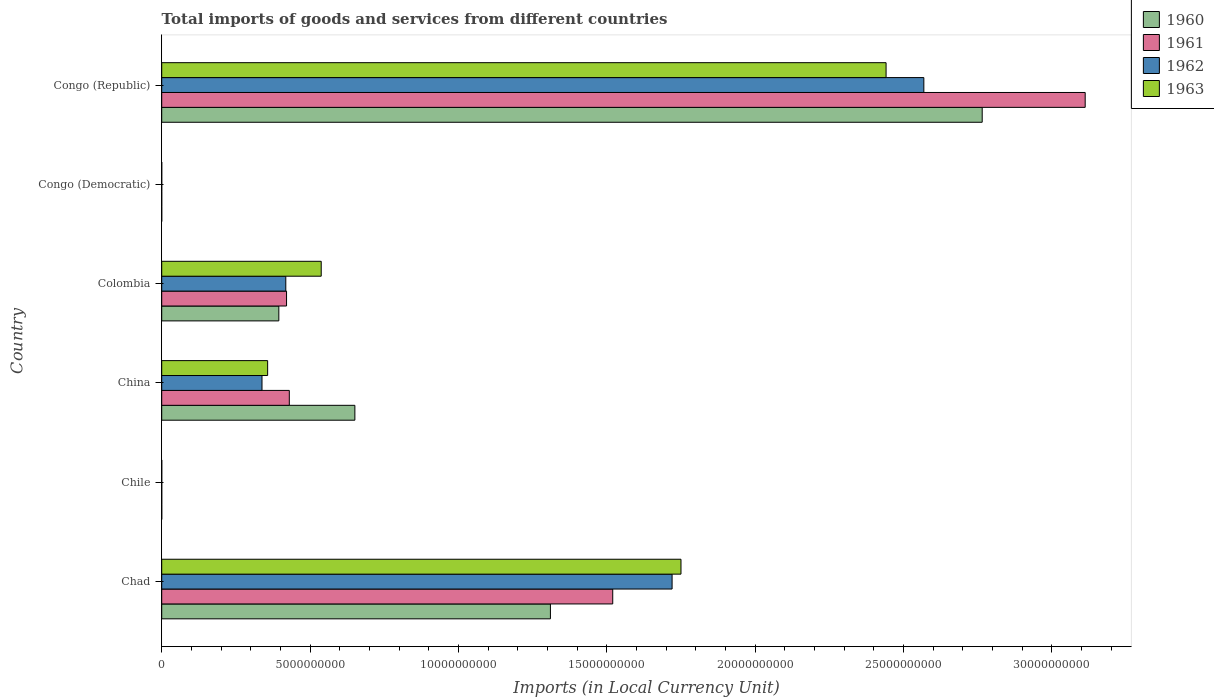How many different coloured bars are there?
Provide a succinct answer. 4. Are the number of bars per tick equal to the number of legend labels?
Your answer should be compact. Yes. How many bars are there on the 2nd tick from the bottom?
Provide a succinct answer. 4. What is the label of the 3rd group of bars from the top?
Ensure brevity in your answer.  Colombia. In how many cases, is the number of bars for a given country not equal to the number of legend labels?
Ensure brevity in your answer.  0. What is the Amount of goods and services imports in 1962 in Congo (Republic)?
Offer a terse response. 2.57e+1. Across all countries, what is the maximum Amount of goods and services imports in 1961?
Offer a terse response. 3.11e+1. Across all countries, what is the minimum Amount of goods and services imports in 1961?
Make the answer very short. 5.07076656504069e-5. In which country was the Amount of goods and services imports in 1963 maximum?
Offer a very short reply. Congo (Republic). In which country was the Amount of goods and services imports in 1961 minimum?
Your answer should be very brief. Congo (Democratic). What is the total Amount of goods and services imports in 1962 in the graph?
Your response must be concise. 5.04e+1. What is the difference between the Amount of goods and services imports in 1960 in Colombia and that in Congo (Republic)?
Make the answer very short. -2.37e+1. What is the difference between the Amount of goods and services imports in 1961 in Chad and the Amount of goods and services imports in 1962 in China?
Ensure brevity in your answer.  1.18e+1. What is the average Amount of goods and services imports in 1963 per country?
Give a very brief answer. 8.48e+09. What is the difference between the Amount of goods and services imports in 1963 and Amount of goods and services imports in 1962 in Colombia?
Your response must be concise. 1.19e+09. What is the ratio of the Amount of goods and services imports in 1960 in Chile to that in Congo (Democratic)?
Give a very brief answer. 6.31e+09. Is the Amount of goods and services imports in 1961 in Chile less than that in Congo (Democratic)?
Offer a very short reply. No. What is the difference between the highest and the second highest Amount of goods and services imports in 1961?
Your answer should be compact. 1.59e+1. What is the difference between the highest and the lowest Amount of goods and services imports in 1963?
Keep it short and to the point. 2.44e+1. Is it the case that in every country, the sum of the Amount of goods and services imports in 1963 and Amount of goods and services imports in 1960 is greater than the sum of Amount of goods and services imports in 1961 and Amount of goods and services imports in 1962?
Provide a short and direct response. No. What does the 1st bar from the top in China represents?
Ensure brevity in your answer.  1963. How many bars are there?
Keep it short and to the point. 24. Are all the bars in the graph horizontal?
Offer a terse response. Yes. How many countries are there in the graph?
Your answer should be compact. 6. Does the graph contain grids?
Keep it short and to the point. No. Where does the legend appear in the graph?
Keep it short and to the point. Top right. How many legend labels are there?
Ensure brevity in your answer.  4. How are the legend labels stacked?
Provide a succinct answer. Vertical. What is the title of the graph?
Offer a terse response. Total imports of goods and services from different countries. Does "1960" appear as one of the legend labels in the graph?
Your answer should be compact. Yes. What is the label or title of the X-axis?
Your response must be concise. Imports (in Local Currency Unit). What is the label or title of the Y-axis?
Provide a short and direct response. Country. What is the Imports (in Local Currency Unit) of 1960 in Chad?
Your answer should be compact. 1.31e+1. What is the Imports (in Local Currency Unit) in 1961 in Chad?
Your answer should be compact. 1.52e+1. What is the Imports (in Local Currency Unit) in 1962 in Chad?
Offer a very short reply. 1.72e+1. What is the Imports (in Local Currency Unit) in 1963 in Chad?
Your response must be concise. 1.75e+1. What is the Imports (in Local Currency Unit) of 1962 in Chile?
Offer a terse response. 8.00e+05. What is the Imports (in Local Currency Unit) of 1963 in Chile?
Make the answer very short. 1.30e+06. What is the Imports (in Local Currency Unit) in 1960 in China?
Your answer should be compact. 6.51e+09. What is the Imports (in Local Currency Unit) of 1961 in China?
Provide a succinct answer. 4.30e+09. What is the Imports (in Local Currency Unit) in 1962 in China?
Give a very brief answer. 3.38e+09. What is the Imports (in Local Currency Unit) in 1963 in China?
Offer a terse response. 3.57e+09. What is the Imports (in Local Currency Unit) in 1960 in Colombia?
Offer a terse response. 3.95e+09. What is the Imports (in Local Currency Unit) in 1961 in Colombia?
Your answer should be very brief. 4.21e+09. What is the Imports (in Local Currency Unit) in 1962 in Colombia?
Provide a short and direct response. 4.18e+09. What is the Imports (in Local Currency Unit) of 1963 in Colombia?
Your response must be concise. 5.38e+09. What is the Imports (in Local Currency Unit) of 1960 in Congo (Democratic)?
Make the answer very short. 0. What is the Imports (in Local Currency Unit) in 1961 in Congo (Democratic)?
Offer a terse response. 5.07076656504069e-5. What is the Imports (in Local Currency Unit) in 1962 in Congo (Democratic)?
Offer a terse response. 5.906629303353841e-5. What is the Imports (in Local Currency Unit) of 1963 in Congo (Democratic)?
Provide a succinct answer. 0. What is the Imports (in Local Currency Unit) in 1960 in Congo (Republic)?
Give a very brief answer. 2.77e+1. What is the Imports (in Local Currency Unit) in 1961 in Congo (Republic)?
Your answer should be compact. 3.11e+1. What is the Imports (in Local Currency Unit) of 1962 in Congo (Republic)?
Your response must be concise. 2.57e+1. What is the Imports (in Local Currency Unit) of 1963 in Congo (Republic)?
Offer a very short reply. 2.44e+1. Across all countries, what is the maximum Imports (in Local Currency Unit) of 1960?
Make the answer very short. 2.77e+1. Across all countries, what is the maximum Imports (in Local Currency Unit) of 1961?
Your answer should be very brief. 3.11e+1. Across all countries, what is the maximum Imports (in Local Currency Unit) of 1962?
Your answer should be very brief. 2.57e+1. Across all countries, what is the maximum Imports (in Local Currency Unit) in 1963?
Your answer should be very brief. 2.44e+1. Across all countries, what is the minimum Imports (in Local Currency Unit) in 1960?
Provide a succinct answer. 0. Across all countries, what is the minimum Imports (in Local Currency Unit) in 1961?
Provide a short and direct response. 5.07076656504069e-5. Across all countries, what is the minimum Imports (in Local Currency Unit) of 1962?
Provide a succinct answer. 5.906629303353841e-5. Across all countries, what is the minimum Imports (in Local Currency Unit) of 1963?
Your answer should be very brief. 0. What is the total Imports (in Local Currency Unit) in 1960 in the graph?
Offer a terse response. 5.12e+1. What is the total Imports (in Local Currency Unit) of 1961 in the graph?
Give a very brief answer. 5.48e+1. What is the total Imports (in Local Currency Unit) in 1962 in the graph?
Give a very brief answer. 5.04e+1. What is the total Imports (in Local Currency Unit) of 1963 in the graph?
Make the answer very short. 5.09e+1. What is the difference between the Imports (in Local Currency Unit) in 1960 in Chad and that in Chile?
Make the answer very short. 1.31e+1. What is the difference between the Imports (in Local Currency Unit) of 1961 in Chad and that in Chile?
Offer a very short reply. 1.52e+1. What is the difference between the Imports (in Local Currency Unit) of 1962 in Chad and that in Chile?
Ensure brevity in your answer.  1.72e+1. What is the difference between the Imports (in Local Currency Unit) of 1963 in Chad and that in Chile?
Offer a very short reply. 1.75e+1. What is the difference between the Imports (in Local Currency Unit) in 1960 in Chad and that in China?
Your response must be concise. 6.59e+09. What is the difference between the Imports (in Local Currency Unit) of 1961 in Chad and that in China?
Provide a succinct answer. 1.09e+1. What is the difference between the Imports (in Local Currency Unit) in 1962 in Chad and that in China?
Your answer should be compact. 1.38e+1. What is the difference between the Imports (in Local Currency Unit) of 1963 in Chad and that in China?
Your response must be concise. 1.39e+1. What is the difference between the Imports (in Local Currency Unit) in 1960 in Chad and that in Colombia?
Offer a terse response. 9.15e+09. What is the difference between the Imports (in Local Currency Unit) of 1961 in Chad and that in Colombia?
Offer a very short reply. 1.10e+1. What is the difference between the Imports (in Local Currency Unit) of 1962 in Chad and that in Colombia?
Provide a succinct answer. 1.30e+1. What is the difference between the Imports (in Local Currency Unit) of 1963 in Chad and that in Colombia?
Provide a succinct answer. 1.21e+1. What is the difference between the Imports (in Local Currency Unit) of 1960 in Chad and that in Congo (Democratic)?
Offer a very short reply. 1.31e+1. What is the difference between the Imports (in Local Currency Unit) in 1961 in Chad and that in Congo (Democratic)?
Your answer should be compact. 1.52e+1. What is the difference between the Imports (in Local Currency Unit) of 1962 in Chad and that in Congo (Democratic)?
Provide a short and direct response. 1.72e+1. What is the difference between the Imports (in Local Currency Unit) of 1963 in Chad and that in Congo (Democratic)?
Ensure brevity in your answer.  1.75e+1. What is the difference between the Imports (in Local Currency Unit) in 1960 in Chad and that in Congo (Republic)?
Offer a terse response. -1.46e+1. What is the difference between the Imports (in Local Currency Unit) of 1961 in Chad and that in Congo (Republic)?
Your answer should be very brief. -1.59e+1. What is the difference between the Imports (in Local Currency Unit) of 1962 in Chad and that in Congo (Republic)?
Your answer should be very brief. -8.48e+09. What is the difference between the Imports (in Local Currency Unit) of 1963 in Chad and that in Congo (Republic)?
Keep it short and to the point. -6.91e+09. What is the difference between the Imports (in Local Currency Unit) of 1960 in Chile and that in China?
Offer a very short reply. -6.51e+09. What is the difference between the Imports (in Local Currency Unit) of 1961 in Chile and that in China?
Your answer should be very brief. -4.30e+09. What is the difference between the Imports (in Local Currency Unit) in 1962 in Chile and that in China?
Give a very brief answer. -3.38e+09. What is the difference between the Imports (in Local Currency Unit) in 1963 in Chile and that in China?
Your answer should be compact. -3.57e+09. What is the difference between the Imports (in Local Currency Unit) in 1960 in Chile and that in Colombia?
Ensure brevity in your answer.  -3.95e+09. What is the difference between the Imports (in Local Currency Unit) of 1961 in Chile and that in Colombia?
Provide a short and direct response. -4.21e+09. What is the difference between the Imports (in Local Currency Unit) of 1962 in Chile and that in Colombia?
Your answer should be compact. -4.18e+09. What is the difference between the Imports (in Local Currency Unit) in 1963 in Chile and that in Colombia?
Give a very brief answer. -5.37e+09. What is the difference between the Imports (in Local Currency Unit) of 1960 in Chile and that in Congo (Democratic)?
Your response must be concise. 7.00e+05. What is the difference between the Imports (in Local Currency Unit) of 1961 in Chile and that in Congo (Democratic)?
Keep it short and to the point. 8.00e+05. What is the difference between the Imports (in Local Currency Unit) in 1962 in Chile and that in Congo (Democratic)?
Provide a succinct answer. 8.00e+05. What is the difference between the Imports (in Local Currency Unit) in 1963 in Chile and that in Congo (Democratic)?
Ensure brevity in your answer.  1.30e+06. What is the difference between the Imports (in Local Currency Unit) of 1960 in Chile and that in Congo (Republic)?
Provide a short and direct response. -2.77e+1. What is the difference between the Imports (in Local Currency Unit) of 1961 in Chile and that in Congo (Republic)?
Give a very brief answer. -3.11e+1. What is the difference between the Imports (in Local Currency Unit) of 1962 in Chile and that in Congo (Republic)?
Offer a very short reply. -2.57e+1. What is the difference between the Imports (in Local Currency Unit) of 1963 in Chile and that in Congo (Republic)?
Your response must be concise. -2.44e+1. What is the difference between the Imports (in Local Currency Unit) of 1960 in China and that in Colombia?
Offer a very short reply. 2.56e+09. What is the difference between the Imports (in Local Currency Unit) in 1961 in China and that in Colombia?
Provide a succinct answer. 9.28e+07. What is the difference between the Imports (in Local Currency Unit) in 1962 in China and that in Colombia?
Your answer should be very brief. -8.02e+08. What is the difference between the Imports (in Local Currency Unit) of 1963 in China and that in Colombia?
Your response must be concise. -1.81e+09. What is the difference between the Imports (in Local Currency Unit) in 1960 in China and that in Congo (Democratic)?
Ensure brevity in your answer.  6.51e+09. What is the difference between the Imports (in Local Currency Unit) in 1961 in China and that in Congo (Democratic)?
Give a very brief answer. 4.30e+09. What is the difference between the Imports (in Local Currency Unit) in 1962 in China and that in Congo (Democratic)?
Your answer should be compact. 3.38e+09. What is the difference between the Imports (in Local Currency Unit) in 1963 in China and that in Congo (Democratic)?
Your answer should be very brief. 3.57e+09. What is the difference between the Imports (in Local Currency Unit) in 1960 in China and that in Congo (Republic)?
Offer a terse response. -2.11e+1. What is the difference between the Imports (in Local Currency Unit) in 1961 in China and that in Congo (Republic)?
Give a very brief answer. -2.68e+1. What is the difference between the Imports (in Local Currency Unit) in 1962 in China and that in Congo (Republic)?
Ensure brevity in your answer.  -2.23e+1. What is the difference between the Imports (in Local Currency Unit) of 1963 in China and that in Congo (Republic)?
Your answer should be very brief. -2.08e+1. What is the difference between the Imports (in Local Currency Unit) in 1960 in Colombia and that in Congo (Democratic)?
Offer a terse response. 3.95e+09. What is the difference between the Imports (in Local Currency Unit) in 1961 in Colombia and that in Congo (Democratic)?
Your response must be concise. 4.21e+09. What is the difference between the Imports (in Local Currency Unit) of 1962 in Colombia and that in Congo (Democratic)?
Offer a very short reply. 4.18e+09. What is the difference between the Imports (in Local Currency Unit) in 1963 in Colombia and that in Congo (Democratic)?
Ensure brevity in your answer.  5.38e+09. What is the difference between the Imports (in Local Currency Unit) in 1960 in Colombia and that in Congo (Republic)?
Provide a succinct answer. -2.37e+1. What is the difference between the Imports (in Local Currency Unit) in 1961 in Colombia and that in Congo (Republic)?
Your answer should be compact. -2.69e+1. What is the difference between the Imports (in Local Currency Unit) in 1962 in Colombia and that in Congo (Republic)?
Provide a short and direct response. -2.15e+1. What is the difference between the Imports (in Local Currency Unit) in 1963 in Colombia and that in Congo (Republic)?
Make the answer very short. -1.90e+1. What is the difference between the Imports (in Local Currency Unit) in 1960 in Congo (Democratic) and that in Congo (Republic)?
Offer a terse response. -2.77e+1. What is the difference between the Imports (in Local Currency Unit) of 1961 in Congo (Democratic) and that in Congo (Republic)?
Your answer should be compact. -3.11e+1. What is the difference between the Imports (in Local Currency Unit) in 1962 in Congo (Democratic) and that in Congo (Republic)?
Ensure brevity in your answer.  -2.57e+1. What is the difference between the Imports (in Local Currency Unit) of 1963 in Congo (Democratic) and that in Congo (Republic)?
Provide a succinct answer. -2.44e+1. What is the difference between the Imports (in Local Currency Unit) in 1960 in Chad and the Imports (in Local Currency Unit) in 1961 in Chile?
Offer a terse response. 1.31e+1. What is the difference between the Imports (in Local Currency Unit) in 1960 in Chad and the Imports (in Local Currency Unit) in 1962 in Chile?
Your answer should be compact. 1.31e+1. What is the difference between the Imports (in Local Currency Unit) in 1960 in Chad and the Imports (in Local Currency Unit) in 1963 in Chile?
Provide a short and direct response. 1.31e+1. What is the difference between the Imports (in Local Currency Unit) of 1961 in Chad and the Imports (in Local Currency Unit) of 1962 in Chile?
Ensure brevity in your answer.  1.52e+1. What is the difference between the Imports (in Local Currency Unit) in 1961 in Chad and the Imports (in Local Currency Unit) in 1963 in Chile?
Provide a short and direct response. 1.52e+1. What is the difference between the Imports (in Local Currency Unit) of 1962 in Chad and the Imports (in Local Currency Unit) of 1963 in Chile?
Offer a terse response. 1.72e+1. What is the difference between the Imports (in Local Currency Unit) in 1960 in Chad and the Imports (in Local Currency Unit) in 1961 in China?
Offer a very short reply. 8.80e+09. What is the difference between the Imports (in Local Currency Unit) of 1960 in Chad and the Imports (in Local Currency Unit) of 1962 in China?
Keep it short and to the point. 9.72e+09. What is the difference between the Imports (in Local Currency Unit) in 1960 in Chad and the Imports (in Local Currency Unit) in 1963 in China?
Keep it short and to the point. 9.53e+09. What is the difference between the Imports (in Local Currency Unit) of 1961 in Chad and the Imports (in Local Currency Unit) of 1962 in China?
Your answer should be compact. 1.18e+1. What is the difference between the Imports (in Local Currency Unit) of 1961 in Chad and the Imports (in Local Currency Unit) of 1963 in China?
Provide a short and direct response. 1.16e+1. What is the difference between the Imports (in Local Currency Unit) in 1962 in Chad and the Imports (in Local Currency Unit) in 1963 in China?
Provide a short and direct response. 1.36e+1. What is the difference between the Imports (in Local Currency Unit) of 1960 in Chad and the Imports (in Local Currency Unit) of 1961 in Colombia?
Offer a very short reply. 8.89e+09. What is the difference between the Imports (in Local Currency Unit) in 1960 in Chad and the Imports (in Local Currency Unit) in 1962 in Colombia?
Make the answer very short. 8.92e+09. What is the difference between the Imports (in Local Currency Unit) in 1960 in Chad and the Imports (in Local Currency Unit) in 1963 in Colombia?
Your answer should be very brief. 7.72e+09. What is the difference between the Imports (in Local Currency Unit) of 1961 in Chad and the Imports (in Local Currency Unit) of 1962 in Colombia?
Your answer should be very brief. 1.10e+1. What is the difference between the Imports (in Local Currency Unit) of 1961 in Chad and the Imports (in Local Currency Unit) of 1963 in Colombia?
Provide a short and direct response. 9.82e+09. What is the difference between the Imports (in Local Currency Unit) of 1962 in Chad and the Imports (in Local Currency Unit) of 1963 in Colombia?
Keep it short and to the point. 1.18e+1. What is the difference between the Imports (in Local Currency Unit) in 1960 in Chad and the Imports (in Local Currency Unit) in 1961 in Congo (Democratic)?
Make the answer very short. 1.31e+1. What is the difference between the Imports (in Local Currency Unit) of 1960 in Chad and the Imports (in Local Currency Unit) of 1962 in Congo (Democratic)?
Your answer should be very brief. 1.31e+1. What is the difference between the Imports (in Local Currency Unit) in 1960 in Chad and the Imports (in Local Currency Unit) in 1963 in Congo (Democratic)?
Provide a short and direct response. 1.31e+1. What is the difference between the Imports (in Local Currency Unit) of 1961 in Chad and the Imports (in Local Currency Unit) of 1962 in Congo (Democratic)?
Give a very brief answer. 1.52e+1. What is the difference between the Imports (in Local Currency Unit) in 1961 in Chad and the Imports (in Local Currency Unit) in 1963 in Congo (Democratic)?
Your answer should be very brief. 1.52e+1. What is the difference between the Imports (in Local Currency Unit) of 1962 in Chad and the Imports (in Local Currency Unit) of 1963 in Congo (Democratic)?
Your response must be concise. 1.72e+1. What is the difference between the Imports (in Local Currency Unit) in 1960 in Chad and the Imports (in Local Currency Unit) in 1961 in Congo (Republic)?
Offer a very short reply. -1.80e+1. What is the difference between the Imports (in Local Currency Unit) in 1960 in Chad and the Imports (in Local Currency Unit) in 1962 in Congo (Republic)?
Keep it short and to the point. -1.26e+1. What is the difference between the Imports (in Local Currency Unit) of 1960 in Chad and the Imports (in Local Currency Unit) of 1963 in Congo (Republic)?
Provide a succinct answer. -1.13e+1. What is the difference between the Imports (in Local Currency Unit) of 1961 in Chad and the Imports (in Local Currency Unit) of 1962 in Congo (Republic)?
Provide a succinct answer. -1.05e+1. What is the difference between the Imports (in Local Currency Unit) of 1961 in Chad and the Imports (in Local Currency Unit) of 1963 in Congo (Republic)?
Make the answer very short. -9.21e+09. What is the difference between the Imports (in Local Currency Unit) of 1962 in Chad and the Imports (in Local Currency Unit) of 1963 in Congo (Republic)?
Your answer should be compact. -7.21e+09. What is the difference between the Imports (in Local Currency Unit) in 1960 in Chile and the Imports (in Local Currency Unit) in 1961 in China?
Keep it short and to the point. -4.30e+09. What is the difference between the Imports (in Local Currency Unit) of 1960 in Chile and the Imports (in Local Currency Unit) of 1962 in China?
Give a very brief answer. -3.38e+09. What is the difference between the Imports (in Local Currency Unit) in 1960 in Chile and the Imports (in Local Currency Unit) in 1963 in China?
Offer a very short reply. -3.57e+09. What is the difference between the Imports (in Local Currency Unit) in 1961 in Chile and the Imports (in Local Currency Unit) in 1962 in China?
Your answer should be compact. -3.38e+09. What is the difference between the Imports (in Local Currency Unit) of 1961 in Chile and the Imports (in Local Currency Unit) of 1963 in China?
Ensure brevity in your answer.  -3.57e+09. What is the difference between the Imports (in Local Currency Unit) of 1962 in Chile and the Imports (in Local Currency Unit) of 1963 in China?
Ensure brevity in your answer.  -3.57e+09. What is the difference between the Imports (in Local Currency Unit) in 1960 in Chile and the Imports (in Local Currency Unit) in 1961 in Colombia?
Make the answer very short. -4.21e+09. What is the difference between the Imports (in Local Currency Unit) in 1960 in Chile and the Imports (in Local Currency Unit) in 1962 in Colombia?
Offer a terse response. -4.18e+09. What is the difference between the Imports (in Local Currency Unit) in 1960 in Chile and the Imports (in Local Currency Unit) in 1963 in Colombia?
Give a very brief answer. -5.37e+09. What is the difference between the Imports (in Local Currency Unit) in 1961 in Chile and the Imports (in Local Currency Unit) in 1962 in Colombia?
Keep it short and to the point. -4.18e+09. What is the difference between the Imports (in Local Currency Unit) in 1961 in Chile and the Imports (in Local Currency Unit) in 1963 in Colombia?
Your answer should be very brief. -5.37e+09. What is the difference between the Imports (in Local Currency Unit) of 1962 in Chile and the Imports (in Local Currency Unit) of 1963 in Colombia?
Keep it short and to the point. -5.37e+09. What is the difference between the Imports (in Local Currency Unit) of 1960 in Chile and the Imports (in Local Currency Unit) of 1961 in Congo (Democratic)?
Your answer should be very brief. 7.00e+05. What is the difference between the Imports (in Local Currency Unit) of 1960 in Chile and the Imports (in Local Currency Unit) of 1962 in Congo (Democratic)?
Give a very brief answer. 7.00e+05. What is the difference between the Imports (in Local Currency Unit) in 1960 in Chile and the Imports (in Local Currency Unit) in 1963 in Congo (Democratic)?
Your answer should be very brief. 7.00e+05. What is the difference between the Imports (in Local Currency Unit) in 1961 in Chile and the Imports (in Local Currency Unit) in 1962 in Congo (Democratic)?
Offer a terse response. 8.00e+05. What is the difference between the Imports (in Local Currency Unit) of 1961 in Chile and the Imports (in Local Currency Unit) of 1963 in Congo (Democratic)?
Offer a very short reply. 8.00e+05. What is the difference between the Imports (in Local Currency Unit) of 1962 in Chile and the Imports (in Local Currency Unit) of 1963 in Congo (Democratic)?
Your answer should be very brief. 8.00e+05. What is the difference between the Imports (in Local Currency Unit) in 1960 in Chile and the Imports (in Local Currency Unit) in 1961 in Congo (Republic)?
Offer a very short reply. -3.11e+1. What is the difference between the Imports (in Local Currency Unit) in 1960 in Chile and the Imports (in Local Currency Unit) in 1962 in Congo (Republic)?
Provide a succinct answer. -2.57e+1. What is the difference between the Imports (in Local Currency Unit) of 1960 in Chile and the Imports (in Local Currency Unit) of 1963 in Congo (Republic)?
Provide a succinct answer. -2.44e+1. What is the difference between the Imports (in Local Currency Unit) of 1961 in Chile and the Imports (in Local Currency Unit) of 1962 in Congo (Republic)?
Offer a terse response. -2.57e+1. What is the difference between the Imports (in Local Currency Unit) in 1961 in Chile and the Imports (in Local Currency Unit) in 1963 in Congo (Republic)?
Offer a very short reply. -2.44e+1. What is the difference between the Imports (in Local Currency Unit) of 1962 in Chile and the Imports (in Local Currency Unit) of 1963 in Congo (Republic)?
Offer a very short reply. -2.44e+1. What is the difference between the Imports (in Local Currency Unit) in 1960 in China and the Imports (in Local Currency Unit) in 1961 in Colombia?
Provide a short and direct response. 2.30e+09. What is the difference between the Imports (in Local Currency Unit) of 1960 in China and the Imports (in Local Currency Unit) of 1962 in Colombia?
Provide a short and direct response. 2.33e+09. What is the difference between the Imports (in Local Currency Unit) in 1960 in China and the Imports (in Local Currency Unit) in 1963 in Colombia?
Offer a very short reply. 1.13e+09. What is the difference between the Imports (in Local Currency Unit) in 1961 in China and the Imports (in Local Currency Unit) in 1962 in Colombia?
Your answer should be very brief. 1.18e+08. What is the difference between the Imports (in Local Currency Unit) of 1961 in China and the Imports (in Local Currency Unit) of 1963 in Colombia?
Provide a succinct answer. -1.08e+09. What is the difference between the Imports (in Local Currency Unit) of 1962 in China and the Imports (in Local Currency Unit) of 1963 in Colombia?
Offer a terse response. -2.00e+09. What is the difference between the Imports (in Local Currency Unit) of 1960 in China and the Imports (in Local Currency Unit) of 1961 in Congo (Democratic)?
Your answer should be very brief. 6.51e+09. What is the difference between the Imports (in Local Currency Unit) in 1960 in China and the Imports (in Local Currency Unit) in 1962 in Congo (Democratic)?
Offer a very short reply. 6.51e+09. What is the difference between the Imports (in Local Currency Unit) in 1960 in China and the Imports (in Local Currency Unit) in 1963 in Congo (Democratic)?
Your answer should be compact. 6.51e+09. What is the difference between the Imports (in Local Currency Unit) of 1961 in China and the Imports (in Local Currency Unit) of 1962 in Congo (Democratic)?
Offer a terse response. 4.30e+09. What is the difference between the Imports (in Local Currency Unit) of 1961 in China and the Imports (in Local Currency Unit) of 1963 in Congo (Democratic)?
Provide a succinct answer. 4.30e+09. What is the difference between the Imports (in Local Currency Unit) in 1962 in China and the Imports (in Local Currency Unit) in 1963 in Congo (Democratic)?
Make the answer very short. 3.38e+09. What is the difference between the Imports (in Local Currency Unit) of 1960 in China and the Imports (in Local Currency Unit) of 1961 in Congo (Republic)?
Your answer should be very brief. -2.46e+1. What is the difference between the Imports (in Local Currency Unit) of 1960 in China and the Imports (in Local Currency Unit) of 1962 in Congo (Republic)?
Offer a very short reply. -1.92e+1. What is the difference between the Imports (in Local Currency Unit) of 1960 in China and the Imports (in Local Currency Unit) of 1963 in Congo (Republic)?
Provide a succinct answer. -1.79e+1. What is the difference between the Imports (in Local Currency Unit) of 1961 in China and the Imports (in Local Currency Unit) of 1962 in Congo (Republic)?
Offer a terse response. -2.14e+1. What is the difference between the Imports (in Local Currency Unit) in 1961 in China and the Imports (in Local Currency Unit) in 1963 in Congo (Republic)?
Offer a terse response. -2.01e+1. What is the difference between the Imports (in Local Currency Unit) of 1962 in China and the Imports (in Local Currency Unit) of 1963 in Congo (Republic)?
Offer a terse response. -2.10e+1. What is the difference between the Imports (in Local Currency Unit) in 1960 in Colombia and the Imports (in Local Currency Unit) in 1961 in Congo (Democratic)?
Give a very brief answer. 3.95e+09. What is the difference between the Imports (in Local Currency Unit) in 1960 in Colombia and the Imports (in Local Currency Unit) in 1962 in Congo (Democratic)?
Offer a very short reply. 3.95e+09. What is the difference between the Imports (in Local Currency Unit) in 1960 in Colombia and the Imports (in Local Currency Unit) in 1963 in Congo (Democratic)?
Provide a succinct answer. 3.95e+09. What is the difference between the Imports (in Local Currency Unit) of 1961 in Colombia and the Imports (in Local Currency Unit) of 1962 in Congo (Democratic)?
Make the answer very short. 4.21e+09. What is the difference between the Imports (in Local Currency Unit) of 1961 in Colombia and the Imports (in Local Currency Unit) of 1963 in Congo (Democratic)?
Your answer should be very brief. 4.21e+09. What is the difference between the Imports (in Local Currency Unit) in 1962 in Colombia and the Imports (in Local Currency Unit) in 1963 in Congo (Democratic)?
Your response must be concise. 4.18e+09. What is the difference between the Imports (in Local Currency Unit) of 1960 in Colombia and the Imports (in Local Currency Unit) of 1961 in Congo (Republic)?
Your answer should be very brief. -2.72e+1. What is the difference between the Imports (in Local Currency Unit) in 1960 in Colombia and the Imports (in Local Currency Unit) in 1962 in Congo (Republic)?
Make the answer very short. -2.17e+1. What is the difference between the Imports (in Local Currency Unit) of 1960 in Colombia and the Imports (in Local Currency Unit) of 1963 in Congo (Republic)?
Offer a very short reply. -2.05e+1. What is the difference between the Imports (in Local Currency Unit) of 1961 in Colombia and the Imports (in Local Currency Unit) of 1962 in Congo (Republic)?
Your answer should be compact. -2.15e+1. What is the difference between the Imports (in Local Currency Unit) in 1961 in Colombia and the Imports (in Local Currency Unit) in 1963 in Congo (Republic)?
Keep it short and to the point. -2.02e+1. What is the difference between the Imports (in Local Currency Unit) in 1962 in Colombia and the Imports (in Local Currency Unit) in 1963 in Congo (Republic)?
Keep it short and to the point. -2.02e+1. What is the difference between the Imports (in Local Currency Unit) in 1960 in Congo (Democratic) and the Imports (in Local Currency Unit) in 1961 in Congo (Republic)?
Your answer should be compact. -3.11e+1. What is the difference between the Imports (in Local Currency Unit) in 1960 in Congo (Democratic) and the Imports (in Local Currency Unit) in 1962 in Congo (Republic)?
Your answer should be compact. -2.57e+1. What is the difference between the Imports (in Local Currency Unit) in 1960 in Congo (Democratic) and the Imports (in Local Currency Unit) in 1963 in Congo (Republic)?
Your answer should be compact. -2.44e+1. What is the difference between the Imports (in Local Currency Unit) in 1961 in Congo (Democratic) and the Imports (in Local Currency Unit) in 1962 in Congo (Republic)?
Provide a short and direct response. -2.57e+1. What is the difference between the Imports (in Local Currency Unit) of 1961 in Congo (Democratic) and the Imports (in Local Currency Unit) of 1963 in Congo (Republic)?
Offer a very short reply. -2.44e+1. What is the difference between the Imports (in Local Currency Unit) in 1962 in Congo (Democratic) and the Imports (in Local Currency Unit) in 1963 in Congo (Republic)?
Your response must be concise. -2.44e+1. What is the average Imports (in Local Currency Unit) of 1960 per country?
Provide a short and direct response. 8.53e+09. What is the average Imports (in Local Currency Unit) of 1961 per country?
Provide a short and direct response. 9.14e+09. What is the average Imports (in Local Currency Unit) of 1962 per country?
Ensure brevity in your answer.  8.41e+09. What is the average Imports (in Local Currency Unit) in 1963 per country?
Make the answer very short. 8.48e+09. What is the difference between the Imports (in Local Currency Unit) of 1960 and Imports (in Local Currency Unit) of 1961 in Chad?
Your answer should be compact. -2.10e+09. What is the difference between the Imports (in Local Currency Unit) of 1960 and Imports (in Local Currency Unit) of 1962 in Chad?
Ensure brevity in your answer.  -4.10e+09. What is the difference between the Imports (in Local Currency Unit) of 1960 and Imports (in Local Currency Unit) of 1963 in Chad?
Your answer should be compact. -4.40e+09. What is the difference between the Imports (in Local Currency Unit) of 1961 and Imports (in Local Currency Unit) of 1962 in Chad?
Make the answer very short. -2.00e+09. What is the difference between the Imports (in Local Currency Unit) in 1961 and Imports (in Local Currency Unit) in 1963 in Chad?
Provide a succinct answer. -2.30e+09. What is the difference between the Imports (in Local Currency Unit) of 1962 and Imports (in Local Currency Unit) of 1963 in Chad?
Ensure brevity in your answer.  -3.00e+08. What is the difference between the Imports (in Local Currency Unit) in 1960 and Imports (in Local Currency Unit) in 1962 in Chile?
Offer a terse response. -1.00e+05. What is the difference between the Imports (in Local Currency Unit) in 1960 and Imports (in Local Currency Unit) in 1963 in Chile?
Provide a short and direct response. -6.00e+05. What is the difference between the Imports (in Local Currency Unit) of 1961 and Imports (in Local Currency Unit) of 1962 in Chile?
Keep it short and to the point. 0. What is the difference between the Imports (in Local Currency Unit) of 1961 and Imports (in Local Currency Unit) of 1963 in Chile?
Your answer should be very brief. -5.00e+05. What is the difference between the Imports (in Local Currency Unit) in 1962 and Imports (in Local Currency Unit) in 1963 in Chile?
Keep it short and to the point. -5.00e+05. What is the difference between the Imports (in Local Currency Unit) of 1960 and Imports (in Local Currency Unit) of 1961 in China?
Offer a terse response. 2.21e+09. What is the difference between the Imports (in Local Currency Unit) of 1960 and Imports (in Local Currency Unit) of 1962 in China?
Your answer should be very brief. 3.13e+09. What is the difference between the Imports (in Local Currency Unit) of 1960 and Imports (in Local Currency Unit) of 1963 in China?
Give a very brief answer. 2.94e+09. What is the difference between the Imports (in Local Currency Unit) in 1961 and Imports (in Local Currency Unit) in 1962 in China?
Make the answer very short. 9.20e+08. What is the difference between the Imports (in Local Currency Unit) in 1961 and Imports (in Local Currency Unit) in 1963 in China?
Offer a terse response. 7.30e+08. What is the difference between the Imports (in Local Currency Unit) in 1962 and Imports (in Local Currency Unit) in 1963 in China?
Offer a terse response. -1.90e+08. What is the difference between the Imports (in Local Currency Unit) in 1960 and Imports (in Local Currency Unit) in 1961 in Colombia?
Give a very brief answer. -2.60e+08. What is the difference between the Imports (in Local Currency Unit) in 1960 and Imports (in Local Currency Unit) in 1962 in Colombia?
Provide a short and direct response. -2.35e+08. What is the difference between the Imports (in Local Currency Unit) in 1960 and Imports (in Local Currency Unit) in 1963 in Colombia?
Offer a terse response. -1.43e+09. What is the difference between the Imports (in Local Currency Unit) of 1961 and Imports (in Local Currency Unit) of 1962 in Colombia?
Your answer should be very brief. 2.55e+07. What is the difference between the Imports (in Local Currency Unit) in 1961 and Imports (in Local Currency Unit) in 1963 in Colombia?
Your response must be concise. -1.17e+09. What is the difference between the Imports (in Local Currency Unit) in 1962 and Imports (in Local Currency Unit) in 1963 in Colombia?
Keep it short and to the point. -1.19e+09. What is the difference between the Imports (in Local Currency Unit) in 1960 and Imports (in Local Currency Unit) in 1963 in Congo (Democratic)?
Give a very brief answer. -0. What is the difference between the Imports (in Local Currency Unit) in 1961 and Imports (in Local Currency Unit) in 1963 in Congo (Democratic)?
Ensure brevity in your answer.  -0. What is the difference between the Imports (in Local Currency Unit) in 1962 and Imports (in Local Currency Unit) in 1963 in Congo (Democratic)?
Ensure brevity in your answer.  -0. What is the difference between the Imports (in Local Currency Unit) of 1960 and Imports (in Local Currency Unit) of 1961 in Congo (Republic)?
Offer a terse response. -3.47e+09. What is the difference between the Imports (in Local Currency Unit) in 1960 and Imports (in Local Currency Unit) in 1962 in Congo (Republic)?
Provide a short and direct response. 1.97e+09. What is the difference between the Imports (in Local Currency Unit) of 1960 and Imports (in Local Currency Unit) of 1963 in Congo (Republic)?
Ensure brevity in your answer.  3.24e+09. What is the difference between the Imports (in Local Currency Unit) in 1961 and Imports (in Local Currency Unit) in 1962 in Congo (Republic)?
Offer a terse response. 5.44e+09. What is the difference between the Imports (in Local Currency Unit) in 1961 and Imports (in Local Currency Unit) in 1963 in Congo (Republic)?
Offer a terse response. 6.71e+09. What is the difference between the Imports (in Local Currency Unit) of 1962 and Imports (in Local Currency Unit) of 1963 in Congo (Republic)?
Ensure brevity in your answer.  1.27e+09. What is the ratio of the Imports (in Local Currency Unit) of 1960 in Chad to that in Chile?
Keep it short and to the point. 1.87e+04. What is the ratio of the Imports (in Local Currency Unit) in 1961 in Chad to that in Chile?
Provide a short and direct response. 1.90e+04. What is the ratio of the Imports (in Local Currency Unit) in 1962 in Chad to that in Chile?
Provide a succinct answer. 2.15e+04. What is the ratio of the Imports (in Local Currency Unit) in 1963 in Chad to that in Chile?
Ensure brevity in your answer.  1.35e+04. What is the ratio of the Imports (in Local Currency Unit) in 1960 in Chad to that in China?
Provide a short and direct response. 2.01. What is the ratio of the Imports (in Local Currency Unit) in 1961 in Chad to that in China?
Offer a terse response. 3.53. What is the ratio of the Imports (in Local Currency Unit) of 1962 in Chad to that in China?
Make the answer very short. 5.09. What is the ratio of the Imports (in Local Currency Unit) in 1963 in Chad to that in China?
Keep it short and to the point. 4.9. What is the ratio of the Imports (in Local Currency Unit) in 1960 in Chad to that in Colombia?
Your answer should be compact. 3.32. What is the ratio of the Imports (in Local Currency Unit) in 1961 in Chad to that in Colombia?
Your response must be concise. 3.61. What is the ratio of the Imports (in Local Currency Unit) of 1962 in Chad to that in Colombia?
Make the answer very short. 4.11. What is the ratio of the Imports (in Local Currency Unit) of 1963 in Chad to that in Colombia?
Make the answer very short. 3.26. What is the ratio of the Imports (in Local Currency Unit) of 1960 in Chad to that in Congo (Democratic)?
Give a very brief answer. 1.18e+14. What is the ratio of the Imports (in Local Currency Unit) of 1961 in Chad to that in Congo (Democratic)?
Your answer should be compact. 3.00e+14. What is the ratio of the Imports (in Local Currency Unit) in 1962 in Chad to that in Congo (Democratic)?
Provide a succinct answer. 2.91e+14. What is the ratio of the Imports (in Local Currency Unit) of 1963 in Chad to that in Congo (Democratic)?
Ensure brevity in your answer.  3.52e+13. What is the ratio of the Imports (in Local Currency Unit) of 1960 in Chad to that in Congo (Republic)?
Make the answer very short. 0.47. What is the ratio of the Imports (in Local Currency Unit) in 1961 in Chad to that in Congo (Republic)?
Your response must be concise. 0.49. What is the ratio of the Imports (in Local Currency Unit) in 1962 in Chad to that in Congo (Republic)?
Offer a terse response. 0.67. What is the ratio of the Imports (in Local Currency Unit) of 1963 in Chad to that in Congo (Republic)?
Provide a short and direct response. 0.72. What is the ratio of the Imports (in Local Currency Unit) of 1962 in Chile to that in Colombia?
Ensure brevity in your answer.  0. What is the ratio of the Imports (in Local Currency Unit) in 1960 in Chile to that in Congo (Democratic)?
Your answer should be very brief. 6.31e+09. What is the ratio of the Imports (in Local Currency Unit) in 1961 in Chile to that in Congo (Democratic)?
Your answer should be compact. 1.58e+1. What is the ratio of the Imports (in Local Currency Unit) in 1962 in Chile to that in Congo (Democratic)?
Keep it short and to the point. 1.35e+1. What is the ratio of the Imports (in Local Currency Unit) of 1963 in Chile to that in Congo (Democratic)?
Offer a very short reply. 2.62e+09. What is the ratio of the Imports (in Local Currency Unit) of 1962 in Chile to that in Congo (Republic)?
Give a very brief answer. 0. What is the ratio of the Imports (in Local Currency Unit) of 1960 in China to that in Colombia?
Your response must be concise. 1.65. What is the ratio of the Imports (in Local Currency Unit) in 1961 in China to that in Colombia?
Keep it short and to the point. 1.02. What is the ratio of the Imports (in Local Currency Unit) of 1962 in China to that in Colombia?
Your answer should be compact. 0.81. What is the ratio of the Imports (in Local Currency Unit) of 1963 in China to that in Colombia?
Provide a short and direct response. 0.66. What is the ratio of the Imports (in Local Currency Unit) of 1960 in China to that in Congo (Democratic)?
Provide a succinct answer. 5.87e+13. What is the ratio of the Imports (in Local Currency Unit) of 1961 in China to that in Congo (Democratic)?
Keep it short and to the point. 8.48e+13. What is the ratio of the Imports (in Local Currency Unit) of 1962 in China to that in Congo (Democratic)?
Your response must be concise. 5.72e+13. What is the ratio of the Imports (in Local Currency Unit) in 1963 in China to that in Congo (Democratic)?
Provide a succinct answer. 7.18e+12. What is the ratio of the Imports (in Local Currency Unit) of 1960 in China to that in Congo (Republic)?
Ensure brevity in your answer.  0.24. What is the ratio of the Imports (in Local Currency Unit) of 1961 in China to that in Congo (Republic)?
Offer a terse response. 0.14. What is the ratio of the Imports (in Local Currency Unit) in 1962 in China to that in Congo (Republic)?
Offer a terse response. 0.13. What is the ratio of the Imports (in Local Currency Unit) in 1963 in China to that in Congo (Republic)?
Your answer should be compact. 0.15. What is the ratio of the Imports (in Local Currency Unit) in 1960 in Colombia to that in Congo (Democratic)?
Your response must be concise. 3.56e+13. What is the ratio of the Imports (in Local Currency Unit) of 1961 in Colombia to that in Congo (Democratic)?
Offer a terse response. 8.30e+13. What is the ratio of the Imports (in Local Currency Unit) of 1962 in Colombia to that in Congo (Democratic)?
Offer a terse response. 7.08e+13. What is the ratio of the Imports (in Local Currency Unit) in 1963 in Colombia to that in Congo (Democratic)?
Make the answer very short. 1.08e+13. What is the ratio of the Imports (in Local Currency Unit) in 1960 in Colombia to that in Congo (Republic)?
Your response must be concise. 0.14. What is the ratio of the Imports (in Local Currency Unit) of 1961 in Colombia to that in Congo (Republic)?
Give a very brief answer. 0.14. What is the ratio of the Imports (in Local Currency Unit) in 1962 in Colombia to that in Congo (Republic)?
Your answer should be very brief. 0.16. What is the ratio of the Imports (in Local Currency Unit) in 1963 in Colombia to that in Congo (Republic)?
Give a very brief answer. 0.22. What is the ratio of the Imports (in Local Currency Unit) of 1962 in Congo (Democratic) to that in Congo (Republic)?
Your answer should be compact. 0. What is the ratio of the Imports (in Local Currency Unit) in 1963 in Congo (Democratic) to that in Congo (Republic)?
Ensure brevity in your answer.  0. What is the difference between the highest and the second highest Imports (in Local Currency Unit) of 1960?
Ensure brevity in your answer.  1.46e+1. What is the difference between the highest and the second highest Imports (in Local Currency Unit) in 1961?
Your response must be concise. 1.59e+1. What is the difference between the highest and the second highest Imports (in Local Currency Unit) of 1962?
Ensure brevity in your answer.  8.48e+09. What is the difference between the highest and the second highest Imports (in Local Currency Unit) in 1963?
Make the answer very short. 6.91e+09. What is the difference between the highest and the lowest Imports (in Local Currency Unit) in 1960?
Ensure brevity in your answer.  2.77e+1. What is the difference between the highest and the lowest Imports (in Local Currency Unit) of 1961?
Your response must be concise. 3.11e+1. What is the difference between the highest and the lowest Imports (in Local Currency Unit) in 1962?
Give a very brief answer. 2.57e+1. What is the difference between the highest and the lowest Imports (in Local Currency Unit) in 1963?
Offer a very short reply. 2.44e+1. 